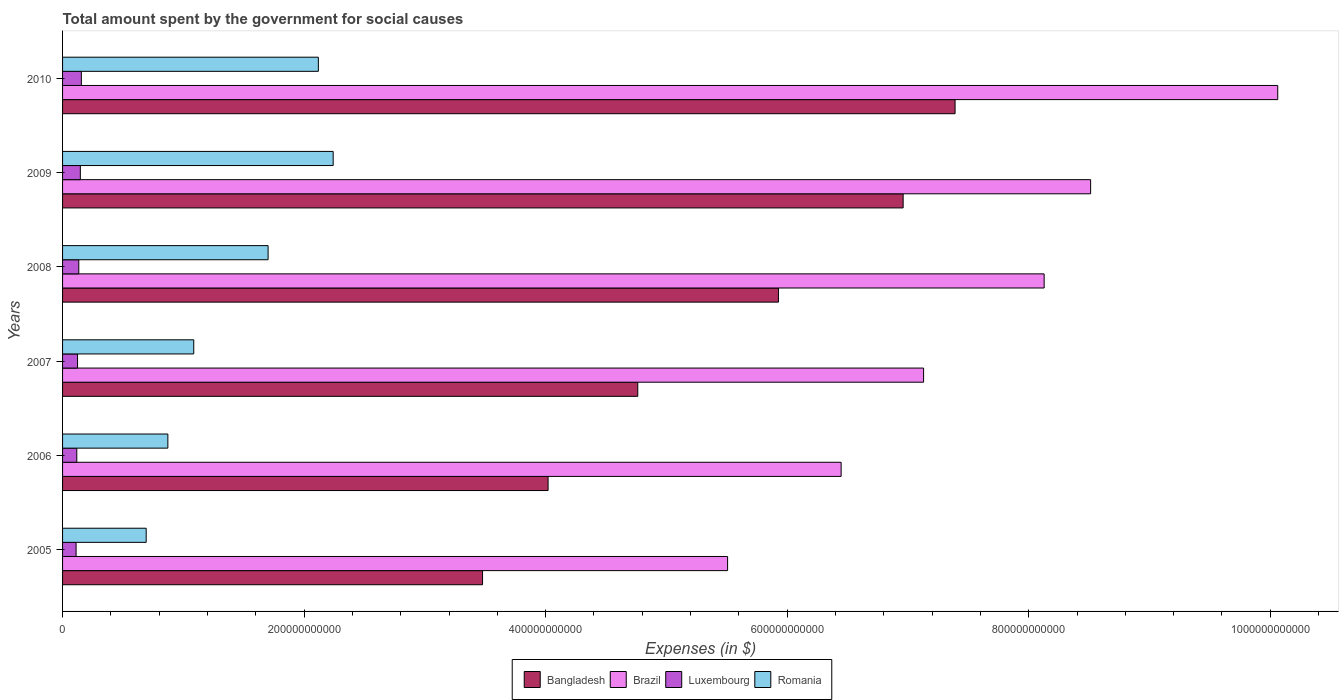How many different coloured bars are there?
Your response must be concise. 4. How many groups of bars are there?
Offer a very short reply. 6. Are the number of bars per tick equal to the number of legend labels?
Keep it short and to the point. Yes. What is the amount spent for social causes by the government in Romania in 2005?
Offer a terse response. 6.92e+1. Across all years, what is the maximum amount spent for social causes by the government in Romania?
Keep it short and to the point. 2.24e+11. Across all years, what is the minimum amount spent for social causes by the government in Bangladesh?
Ensure brevity in your answer.  3.48e+11. In which year was the amount spent for social causes by the government in Brazil minimum?
Give a very brief answer. 2005. What is the total amount spent for social causes by the government in Brazil in the graph?
Your answer should be very brief. 4.58e+12. What is the difference between the amount spent for social causes by the government in Brazil in 2008 and that in 2010?
Offer a terse response. -1.93e+11. What is the difference between the amount spent for social causes by the government in Brazil in 2008 and the amount spent for social causes by the government in Luxembourg in 2007?
Give a very brief answer. 8.00e+11. What is the average amount spent for social causes by the government in Romania per year?
Provide a short and direct response. 1.45e+11. In the year 2005, what is the difference between the amount spent for social causes by the government in Bangladesh and amount spent for social causes by the government in Luxembourg?
Your answer should be very brief. 3.37e+11. What is the ratio of the amount spent for social causes by the government in Romania in 2006 to that in 2007?
Ensure brevity in your answer.  0.8. Is the amount spent for social causes by the government in Brazil in 2005 less than that in 2010?
Provide a short and direct response. Yes. Is the difference between the amount spent for social causes by the government in Bangladesh in 2005 and 2006 greater than the difference between the amount spent for social causes by the government in Luxembourg in 2005 and 2006?
Make the answer very short. No. What is the difference between the highest and the second highest amount spent for social causes by the government in Romania?
Make the answer very short. 1.23e+1. What is the difference between the highest and the lowest amount spent for social causes by the government in Romania?
Provide a short and direct response. 1.55e+11. Is the sum of the amount spent for social causes by the government in Bangladesh in 2007 and 2010 greater than the maximum amount spent for social causes by the government in Romania across all years?
Provide a short and direct response. Yes. How many bars are there?
Make the answer very short. 24. Are all the bars in the graph horizontal?
Your answer should be very brief. Yes. How many years are there in the graph?
Your answer should be compact. 6. What is the difference between two consecutive major ticks on the X-axis?
Your answer should be compact. 2.00e+11. Are the values on the major ticks of X-axis written in scientific E-notation?
Ensure brevity in your answer.  No. Does the graph contain any zero values?
Ensure brevity in your answer.  No. Where does the legend appear in the graph?
Your response must be concise. Bottom center. How many legend labels are there?
Make the answer very short. 4. What is the title of the graph?
Offer a terse response. Total amount spent by the government for social causes. What is the label or title of the X-axis?
Make the answer very short. Expenses (in $). What is the label or title of the Y-axis?
Give a very brief answer. Years. What is the Expenses (in $) in Bangladesh in 2005?
Your answer should be very brief. 3.48e+11. What is the Expenses (in $) in Brazil in 2005?
Give a very brief answer. 5.51e+11. What is the Expenses (in $) of Luxembourg in 2005?
Offer a terse response. 1.12e+1. What is the Expenses (in $) in Romania in 2005?
Provide a succinct answer. 6.92e+1. What is the Expenses (in $) in Bangladesh in 2006?
Make the answer very short. 4.02e+11. What is the Expenses (in $) of Brazil in 2006?
Offer a very short reply. 6.45e+11. What is the Expenses (in $) in Luxembourg in 2006?
Give a very brief answer. 1.18e+1. What is the Expenses (in $) in Romania in 2006?
Provide a short and direct response. 8.72e+1. What is the Expenses (in $) in Bangladesh in 2007?
Offer a terse response. 4.76e+11. What is the Expenses (in $) of Brazil in 2007?
Ensure brevity in your answer.  7.13e+11. What is the Expenses (in $) in Luxembourg in 2007?
Offer a very short reply. 1.24e+1. What is the Expenses (in $) in Romania in 2007?
Provide a succinct answer. 1.09e+11. What is the Expenses (in $) of Bangladesh in 2008?
Give a very brief answer. 5.93e+11. What is the Expenses (in $) of Brazil in 2008?
Your answer should be compact. 8.13e+11. What is the Expenses (in $) of Luxembourg in 2008?
Make the answer very short. 1.34e+1. What is the Expenses (in $) in Romania in 2008?
Offer a very short reply. 1.70e+11. What is the Expenses (in $) of Bangladesh in 2009?
Provide a short and direct response. 6.96e+11. What is the Expenses (in $) in Brazil in 2009?
Your answer should be very brief. 8.51e+11. What is the Expenses (in $) in Luxembourg in 2009?
Offer a very short reply. 1.47e+1. What is the Expenses (in $) of Romania in 2009?
Keep it short and to the point. 2.24e+11. What is the Expenses (in $) of Bangladesh in 2010?
Offer a terse response. 7.39e+11. What is the Expenses (in $) in Brazil in 2010?
Give a very brief answer. 1.01e+12. What is the Expenses (in $) in Luxembourg in 2010?
Your answer should be compact. 1.56e+1. What is the Expenses (in $) in Romania in 2010?
Make the answer very short. 2.12e+11. Across all years, what is the maximum Expenses (in $) in Bangladesh?
Keep it short and to the point. 7.39e+11. Across all years, what is the maximum Expenses (in $) in Brazil?
Your answer should be very brief. 1.01e+12. Across all years, what is the maximum Expenses (in $) of Luxembourg?
Your answer should be very brief. 1.56e+1. Across all years, what is the maximum Expenses (in $) in Romania?
Offer a terse response. 2.24e+11. Across all years, what is the minimum Expenses (in $) in Bangladesh?
Your answer should be very brief. 3.48e+11. Across all years, what is the minimum Expenses (in $) in Brazil?
Your answer should be very brief. 5.51e+11. Across all years, what is the minimum Expenses (in $) of Luxembourg?
Offer a very short reply. 1.12e+1. Across all years, what is the minimum Expenses (in $) of Romania?
Offer a terse response. 6.92e+1. What is the total Expenses (in $) of Bangladesh in the graph?
Offer a very short reply. 3.25e+12. What is the total Expenses (in $) of Brazil in the graph?
Ensure brevity in your answer.  4.58e+12. What is the total Expenses (in $) in Luxembourg in the graph?
Offer a terse response. 7.91e+1. What is the total Expenses (in $) of Romania in the graph?
Your answer should be compact. 8.71e+11. What is the difference between the Expenses (in $) in Bangladesh in 2005 and that in 2006?
Keep it short and to the point. -5.43e+1. What is the difference between the Expenses (in $) of Brazil in 2005 and that in 2006?
Provide a succinct answer. -9.40e+1. What is the difference between the Expenses (in $) of Luxembourg in 2005 and that in 2006?
Offer a very short reply. -5.80e+08. What is the difference between the Expenses (in $) in Romania in 2005 and that in 2006?
Your answer should be very brief. -1.80e+1. What is the difference between the Expenses (in $) in Bangladesh in 2005 and that in 2007?
Provide a succinct answer. -1.29e+11. What is the difference between the Expenses (in $) in Brazil in 2005 and that in 2007?
Your answer should be very brief. -1.62e+11. What is the difference between the Expenses (in $) of Luxembourg in 2005 and that in 2007?
Offer a terse response. -1.21e+09. What is the difference between the Expenses (in $) of Romania in 2005 and that in 2007?
Your response must be concise. -3.94e+1. What is the difference between the Expenses (in $) in Bangladesh in 2005 and that in 2008?
Make the answer very short. -2.45e+11. What is the difference between the Expenses (in $) in Brazil in 2005 and that in 2008?
Give a very brief answer. -2.62e+11. What is the difference between the Expenses (in $) in Luxembourg in 2005 and that in 2008?
Provide a succinct answer. -2.24e+09. What is the difference between the Expenses (in $) in Romania in 2005 and that in 2008?
Offer a terse response. -1.01e+11. What is the difference between the Expenses (in $) of Bangladesh in 2005 and that in 2009?
Your answer should be compact. -3.48e+11. What is the difference between the Expenses (in $) of Brazil in 2005 and that in 2009?
Your answer should be compact. -3.01e+11. What is the difference between the Expenses (in $) in Luxembourg in 2005 and that in 2009?
Your answer should be very brief. -3.51e+09. What is the difference between the Expenses (in $) in Romania in 2005 and that in 2009?
Provide a succinct answer. -1.55e+11. What is the difference between the Expenses (in $) of Bangladesh in 2005 and that in 2010?
Offer a terse response. -3.91e+11. What is the difference between the Expenses (in $) in Brazil in 2005 and that in 2010?
Provide a short and direct response. -4.56e+11. What is the difference between the Expenses (in $) in Luxembourg in 2005 and that in 2010?
Offer a very short reply. -4.35e+09. What is the difference between the Expenses (in $) in Romania in 2005 and that in 2010?
Your answer should be very brief. -1.43e+11. What is the difference between the Expenses (in $) of Bangladesh in 2006 and that in 2007?
Your answer should be compact. -7.43e+1. What is the difference between the Expenses (in $) in Brazil in 2006 and that in 2007?
Your response must be concise. -6.83e+1. What is the difference between the Expenses (in $) of Luxembourg in 2006 and that in 2007?
Offer a terse response. -6.28e+08. What is the difference between the Expenses (in $) of Romania in 2006 and that in 2007?
Your answer should be compact. -2.14e+1. What is the difference between the Expenses (in $) in Bangladesh in 2006 and that in 2008?
Keep it short and to the point. -1.91e+11. What is the difference between the Expenses (in $) in Brazil in 2006 and that in 2008?
Ensure brevity in your answer.  -1.68e+11. What is the difference between the Expenses (in $) in Luxembourg in 2006 and that in 2008?
Make the answer very short. -1.66e+09. What is the difference between the Expenses (in $) in Romania in 2006 and that in 2008?
Provide a short and direct response. -8.30e+1. What is the difference between the Expenses (in $) in Bangladesh in 2006 and that in 2009?
Make the answer very short. -2.94e+11. What is the difference between the Expenses (in $) of Brazil in 2006 and that in 2009?
Your response must be concise. -2.07e+11. What is the difference between the Expenses (in $) of Luxembourg in 2006 and that in 2009?
Keep it short and to the point. -2.93e+09. What is the difference between the Expenses (in $) in Romania in 2006 and that in 2009?
Ensure brevity in your answer.  -1.37e+11. What is the difference between the Expenses (in $) of Bangladesh in 2006 and that in 2010?
Keep it short and to the point. -3.37e+11. What is the difference between the Expenses (in $) in Brazil in 2006 and that in 2010?
Your answer should be compact. -3.62e+11. What is the difference between the Expenses (in $) of Luxembourg in 2006 and that in 2010?
Provide a short and direct response. -3.77e+09. What is the difference between the Expenses (in $) in Romania in 2006 and that in 2010?
Ensure brevity in your answer.  -1.25e+11. What is the difference between the Expenses (in $) of Bangladesh in 2007 and that in 2008?
Keep it short and to the point. -1.16e+11. What is the difference between the Expenses (in $) in Brazil in 2007 and that in 2008?
Keep it short and to the point. -9.98e+1. What is the difference between the Expenses (in $) in Luxembourg in 2007 and that in 2008?
Provide a succinct answer. -1.03e+09. What is the difference between the Expenses (in $) of Romania in 2007 and that in 2008?
Ensure brevity in your answer.  -6.16e+1. What is the difference between the Expenses (in $) of Bangladesh in 2007 and that in 2009?
Your response must be concise. -2.20e+11. What is the difference between the Expenses (in $) of Brazil in 2007 and that in 2009?
Give a very brief answer. -1.38e+11. What is the difference between the Expenses (in $) in Luxembourg in 2007 and that in 2009?
Offer a very short reply. -2.31e+09. What is the difference between the Expenses (in $) in Romania in 2007 and that in 2009?
Your answer should be compact. -1.15e+11. What is the difference between the Expenses (in $) of Bangladesh in 2007 and that in 2010?
Keep it short and to the point. -2.63e+11. What is the difference between the Expenses (in $) in Brazil in 2007 and that in 2010?
Your answer should be compact. -2.93e+11. What is the difference between the Expenses (in $) in Luxembourg in 2007 and that in 2010?
Provide a succinct answer. -3.14e+09. What is the difference between the Expenses (in $) in Romania in 2007 and that in 2010?
Your response must be concise. -1.03e+11. What is the difference between the Expenses (in $) in Bangladesh in 2008 and that in 2009?
Keep it short and to the point. -1.03e+11. What is the difference between the Expenses (in $) in Brazil in 2008 and that in 2009?
Offer a very short reply. -3.85e+1. What is the difference between the Expenses (in $) in Luxembourg in 2008 and that in 2009?
Ensure brevity in your answer.  -1.27e+09. What is the difference between the Expenses (in $) in Romania in 2008 and that in 2009?
Give a very brief answer. -5.39e+1. What is the difference between the Expenses (in $) of Bangladesh in 2008 and that in 2010?
Provide a short and direct response. -1.46e+11. What is the difference between the Expenses (in $) of Brazil in 2008 and that in 2010?
Your response must be concise. -1.93e+11. What is the difference between the Expenses (in $) in Luxembourg in 2008 and that in 2010?
Make the answer very short. -2.11e+09. What is the difference between the Expenses (in $) of Romania in 2008 and that in 2010?
Offer a terse response. -4.16e+1. What is the difference between the Expenses (in $) in Bangladesh in 2009 and that in 2010?
Make the answer very short. -4.30e+1. What is the difference between the Expenses (in $) of Brazil in 2009 and that in 2010?
Offer a very short reply. -1.55e+11. What is the difference between the Expenses (in $) in Luxembourg in 2009 and that in 2010?
Offer a very short reply. -8.37e+08. What is the difference between the Expenses (in $) in Romania in 2009 and that in 2010?
Ensure brevity in your answer.  1.23e+1. What is the difference between the Expenses (in $) in Bangladesh in 2005 and the Expenses (in $) in Brazil in 2006?
Provide a succinct answer. -2.97e+11. What is the difference between the Expenses (in $) of Bangladesh in 2005 and the Expenses (in $) of Luxembourg in 2006?
Ensure brevity in your answer.  3.36e+11. What is the difference between the Expenses (in $) of Bangladesh in 2005 and the Expenses (in $) of Romania in 2006?
Give a very brief answer. 2.61e+11. What is the difference between the Expenses (in $) in Brazil in 2005 and the Expenses (in $) in Luxembourg in 2006?
Keep it short and to the point. 5.39e+11. What is the difference between the Expenses (in $) in Brazil in 2005 and the Expenses (in $) in Romania in 2006?
Keep it short and to the point. 4.63e+11. What is the difference between the Expenses (in $) in Luxembourg in 2005 and the Expenses (in $) in Romania in 2006?
Ensure brevity in your answer.  -7.60e+1. What is the difference between the Expenses (in $) in Bangladesh in 2005 and the Expenses (in $) in Brazil in 2007?
Keep it short and to the point. -3.65e+11. What is the difference between the Expenses (in $) in Bangladesh in 2005 and the Expenses (in $) in Luxembourg in 2007?
Your answer should be very brief. 3.35e+11. What is the difference between the Expenses (in $) in Bangladesh in 2005 and the Expenses (in $) in Romania in 2007?
Your answer should be very brief. 2.39e+11. What is the difference between the Expenses (in $) of Brazil in 2005 and the Expenses (in $) of Luxembourg in 2007?
Your answer should be very brief. 5.38e+11. What is the difference between the Expenses (in $) of Brazil in 2005 and the Expenses (in $) of Romania in 2007?
Keep it short and to the point. 4.42e+11. What is the difference between the Expenses (in $) of Luxembourg in 2005 and the Expenses (in $) of Romania in 2007?
Your response must be concise. -9.74e+1. What is the difference between the Expenses (in $) in Bangladesh in 2005 and the Expenses (in $) in Brazil in 2008?
Your answer should be very brief. -4.65e+11. What is the difference between the Expenses (in $) of Bangladesh in 2005 and the Expenses (in $) of Luxembourg in 2008?
Provide a succinct answer. 3.34e+11. What is the difference between the Expenses (in $) in Bangladesh in 2005 and the Expenses (in $) in Romania in 2008?
Keep it short and to the point. 1.78e+11. What is the difference between the Expenses (in $) of Brazil in 2005 and the Expenses (in $) of Luxembourg in 2008?
Ensure brevity in your answer.  5.37e+11. What is the difference between the Expenses (in $) in Brazil in 2005 and the Expenses (in $) in Romania in 2008?
Offer a terse response. 3.80e+11. What is the difference between the Expenses (in $) of Luxembourg in 2005 and the Expenses (in $) of Romania in 2008?
Your answer should be compact. -1.59e+11. What is the difference between the Expenses (in $) of Bangladesh in 2005 and the Expenses (in $) of Brazil in 2009?
Make the answer very short. -5.04e+11. What is the difference between the Expenses (in $) of Bangladesh in 2005 and the Expenses (in $) of Luxembourg in 2009?
Offer a terse response. 3.33e+11. What is the difference between the Expenses (in $) in Bangladesh in 2005 and the Expenses (in $) in Romania in 2009?
Keep it short and to the point. 1.24e+11. What is the difference between the Expenses (in $) of Brazil in 2005 and the Expenses (in $) of Luxembourg in 2009?
Provide a succinct answer. 5.36e+11. What is the difference between the Expenses (in $) in Brazil in 2005 and the Expenses (in $) in Romania in 2009?
Give a very brief answer. 3.27e+11. What is the difference between the Expenses (in $) in Luxembourg in 2005 and the Expenses (in $) in Romania in 2009?
Make the answer very short. -2.13e+11. What is the difference between the Expenses (in $) in Bangladesh in 2005 and the Expenses (in $) in Brazil in 2010?
Ensure brevity in your answer.  -6.58e+11. What is the difference between the Expenses (in $) of Bangladesh in 2005 and the Expenses (in $) of Luxembourg in 2010?
Give a very brief answer. 3.32e+11. What is the difference between the Expenses (in $) of Bangladesh in 2005 and the Expenses (in $) of Romania in 2010?
Provide a succinct answer. 1.36e+11. What is the difference between the Expenses (in $) in Brazil in 2005 and the Expenses (in $) in Luxembourg in 2010?
Your answer should be very brief. 5.35e+11. What is the difference between the Expenses (in $) of Brazil in 2005 and the Expenses (in $) of Romania in 2010?
Give a very brief answer. 3.39e+11. What is the difference between the Expenses (in $) in Luxembourg in 2005 and the Expenses (in $) in Romania in 2010?
Keep it short and to the point. -2.01e+11. What is the difference between the Expenses (in $) of Bangladesh in 2006 and the Expenses (in $) of Brazil in 2007?
Make the answer very short. -3.11e+11. What is the difference between the Expenses (in $) in Bangladesh in 2006 and the Expenses (in $) in Luxembourg in 2007?
Ensure brevity in your answer.  3.90e+11. What is the difference between the Expenses (in $) of Bangladesh in 2006 and the Expenses (in $) of Romania in 2007?
Your answer should be very brief. 2.93e+11. What is the difference between the Expenses (in $) in Brazil in 2006 and the Expenses (in $) in Luxembourg in 2007?
Ensure brevity in your answer.  6.32e+11. What is the difference between the Expenses (in $) in Brazil in 2006 and the Expenses (in $) in Romania in 2007?
Your answer should be very brief. 5.36e+11. What is the difference between the Expenses (in $) in Luxembourg in 2006 and the Expenses (in $) in Romania in 2007?
Make the answer very short. -9.68e+1. What is the difference between the Expenses (in $) in Bangladesh in 2006 and the Expenses (in $) in Brazil in 2008?
Keep it short and to the point. -4.11e+11. What is the difference between the Expenses (in $) of Bangladesh in 2006 and the Expenses (in $) of Luxembourg in 2008?
Make the answer very short. 3.89e+11. What is the difference between the Expenses (in $) in Bangladesh in 2006 and the Expenses (in $) in Romania in 2008?
Give a very brief answer. 2.32e+11. What is the difference between the Expenses (in $) in Brazil in 2006 and the Expenses (in $) in Luxembourg in 2008?
Your response must be concise. 6.31e+11. What is the difference between the Expenses (in $) of Brazil in 2006 and the Expenses (in $) of Romania in 2008?
Keep it short and to the point. 4.74e+11. What is the difference between the Expenses (in $) in Luxembourg in 2006 and the Expenses (in $) in Romania in 2008?
Offer a very short reply. -1.58e+11. What is the difference between the Expenses (in $) of Bangladesh in 2006 and the Expenses (in $) of Brazil in 2009?
Keep it short and to the point. -4.49e+11. What is the difference between the Expenses (in $) in Bangladesh in 2006 and the Expenses (in $) in Luxembourg in 2009?
Ensure brevity in your answer.  3.87e+11. What is the difference between the Expenses (in $) of Bangladesh in 2006 and the Expenses (in $) of Romania in 2009?
Offer a very short reply. 1.78e+11. What is the difference between the Expenses (in $) in Brazil in 2006 and the Expenses (in $) in Luxembourg in 2009?
Your answer should be very brief. 6.30e+11. What is the difference between the Expenses (in $) of Brazil in 2006 and the Expenses (in $) of Romania in 2009?
Keep it short and to the point. 4.21e+11. What is the difference between the Expenses (in $) of Luxembourg in 2006 and the Expenses (in $) of Romania in 2009?
Provide a succinct answer. -2.12e+11. What is the difference between the Expenses (in $) in Bangladesh in 2006 and the Expenses (in $) in Brazil in 2010?
Keep it short and to the point. -6.04e+11. What is the difference between the Expenses (in $) in Bangladesh in 2006 and the Expenses (in $) in Luxembourg in 2010?
Keep it short and to the point. 3.86e+11. What is the difference between the Expenses (in $) in Bangladesh in 2006 and the Expenses (in $) in Romania in 2010?
Your response must be concise. 1.90e+11. What is the difference between the Expenses (in $) of Brazil in 2006 and the Expenses (in $) of Luxembourg in 2010?
Keep it short and to the point. 6.29e+11. What is the difference between the Expenses (in $) in Brazil in 2006 and the Expenses (in $) in Romania in 2010?
Provide a succinct answer. 4.33e+11. What is the difference between the Expenses (in $) of Luxembourg in 2006 and the Expenses (in $) of Romania in 2010?
Provide a short and direct response. -2.00e+11. What is the difference between the Expenses (in $) of Bangladesh in 2007 and the Expenses (in $) of Brazil in 2008?
Provide a succinct answer. -3.36e+11. What is the difference between the Expenses (in $) in Bangladesh in 2007 and the Expenses (in $) in Luxembourg in 2008?
Offer a terse response. 4.63e+11. What is the difference between the Expenses (in $) in Bangladesh in 2007 and the Expenses (in $) in Romania in 2008?
Make the answer very short. 3.06e+11. What is the difference between the Expenses (in $) in Brazil in 2007 and the Expenses (in $) in Luxembourg in 2008?
Your response must be concise. 7.00e+11. What is the difference between the Expenses (in $) of Brazil in 2007 and the Expenses (in $) of Romania in 2008?
Your response must be concise. 5.43e+11. What is the difference between the Expenses (in $) in Luxembourg in 2007 and the Expenses (in $) in Romania in 2008?
Ensure brevity in your answer.  -1.58e+11. What is the difference between the Expenses (in $) in Bangladesh in 2007 and the Expenses (in $) in Brazil in 2009?
Offer a very short reply. -3.75e+11. What is the difference between the Expenses (in $) in Bangladesh in 2007 and the Expenses (in $) in Luxembourg in 2009?
Make the answer very short. 4.62e+11. What is the difference between the Expenses (in $) in Bangladesh in 2007 and the Expenses (in $) in Romania in 2009?
Provide a succinct answer. 2.52e+11. What is the difference between the Expenses (in $) of Brazil in 2007 and the Expenses (in $) of Luxembourg in 2009?
Offer a terse response. 6.98e+11. What is the difference between the Expenses (in $) of Brazil in 2007 and the Expenses (in $) of Romania in 2009?
Provide a short and direct response. 4.89e+11. What is the difference between the Expenses (in $) in Luxembourg in 2007 and the Expenses (in $) in Romania in 2009?
Your answer should be very brief. -2.12e+11. What is the difference between the Expenses (in $) of Bangladesh in 2007 and the Expenses (in $) of Brazil in 2010?
Offer a very short reply. -5.30e+11. What is the difference between the Expenses (in $) of Bangladesh in 2007 and the Expenses (in $) of Luxembourg in 2010?
Offer a very short reply. 4.61e+11. What is the difference between the Expenses (in $) in Bangladesh in 2007 and the Expenses (in $) in Romania in 2010?
Ensure brevity in your answer.  2.64e+11. What is the difference between the Expenses (in $) in Brazil in 2007 and the Expenses (in $) in Luxembourg in 2010?
Offer a terse response. 6.97e+11. What is the difference between the Expenses (in $) in Brazil in 2007 and the Expenses (in $) in Romania in 2010?
Give a very brief answer. 5.01e+11. What is the difference between the Expenses (in $) of Luxembourg in 2007 and the Expenses (in $) of Romania in 2010?
Offer a terse response. -1.99e+11. What is the difference between the Expenses (in $) of Bangladesh in 2008 and the Expenses (in $) of Brazil in 2009?
Your response must be concise. -2.58e+11. What is the difference between the Expenses (in $) of Bangladesh in 2008 and the Expenses (in $) of Luxembourg in 2009?
Offer a very short reply. 5.78e+11. What is the difference between the Expenses (in $) in Bangladesh in 2008 and the Expenses (in $) in Romania in 2009?
Ensure brevity in your answer.  3.69e+11. What is the difference between the Expenses (in $) of Brazil in 2008 and the Expenses (in $) of Luxembourg in 2009?
Offer a terse response. 7.98e+11. What is the difference between the Expenses (in $) in Brazil in 2008 and the Expenses (in $) in Romania in 2009?
Your response must be concise. 5.89e+11. What is the difference between the Expenses (in $) in Luxembourg in 2008 and the Expenses (in $) in Romania in 2009?
Provide a short and direct response. -2.11e+11. What is the difference between the Expenses (in $) of Bangladesh in 2008 and the Expenses (in $) of Brazil in 2010?
Keep it short and to the point. -4.13e+11. What is the difference between the Expenses (in $) of Bangladesh in 2008 and the Expenses (in $) of Luxembourg in 2010?
Make the answer very short. 5.77e+11. What is the difference between the Expenses (in $) of Bangladesh in 2008 and the Expenses (in $) of Romania in 2010?
Offer a very short reply. 3.81e+11. What is the difference between the Expenses (in $) of Brazil in 2008 and the Expenses (in $) of Luxembourg in 2010?
Offer a very short reply. 7.97e+11. What is the difference between the Expenses (in $) in Brazil in 2008 and the Expenses (in $) in Romania in 2010?
Keep it short and to the point. 6.01e+11. What is the difference between the Expenses (in $) in Luxembourg in 2008 and the Expenses (in $) in Romania in 2010?
Provide a succinct answer. -1.98e+11. What is the difference between the Expenses (in $) of Bangladesh in 2009 and the Expenses (in $) of Brazil in 2010?
Provide a succinct answer. -3.10e+11. What is the difference between the Expenses (in $) in Bangladesh in 2009 and the Expenses (in $) in Luxembourg in 2010?
Offer a very short reply. 6.80e+11. What is the difference between the Expenses (in $) of Bangladesh in 2009 and the Expenses (in $) of Romania in 2010?
Your response must be concise. 4.84e+11. What is the difference between the Expenses (in $) in Brazil in 2009 and the Expenses (in $) in Luxembourg in 2010?
Your response must be concise. 8.36e+11. What is the difference between the Expenses (in $) in Brazil in 2009 and the Expenses (in $) in Romania in 2010?
Provide a short and direct response. 6.39e+11. What is the difference between the Expenses (in $) of Luxembourg in 2009 and the Expenses (in $) of Romania in 2010?
Offer a very short reply. -1.97e+11. What is the average Expenses (in $) of Bangladesh per year?
Your answer should be compact. 5.42e+11. What is the average Expenses (in $) of Brazil per year?
Offer a very short reply. 7.63e+11. What is the average Expenses (in $) in Luxembourg per year?
Provide a succinct answer. 1.32e+1. What is the average Expenses (in $) of Romania per year?
Your answer should be very brief. 1.45e+11. In the year 2005, what is the difference between the Expenses (in $) in Bangladesh and Expenses (in $) in Brazil?
Offer a very short reply. -2.03e+11. In the year 2005, what is the difference between the Expenses (in $) of Bangladesh and Expenses (in $) of Luxembourg?
Provide a short and direct response. 3.37e+11. In the year 2005, what is the difference between the Expenses (in $) of Bangladesh and Expenses (in $) of Romania?
Provide a short and direct response. 2.79e+11. In the year 2005, what is the difference between the Expenses (in $) of Brazil and Expenses (in $) of Luxembourg?
Your answer should be compact. 5.39e+11. In the year 2005, what is the difference between the Expenses (in $) of Brazil and Expenses (in $) of Romania?
Your answer should be compact. 4.81e+11. In the year 2005, what is the difference between the Expenses (in $) in Luxembourg and Expenses (in $) in Romania?
Your answer should be compact. -5.80e+1. In the year 2006, what is the difference between the Expenses (in $) of Bangladesh and Expenses (in $) of Brazil?
Provide a short and direct response. -2.43e+11. In the year 2006, what is the difference between the Expenses (in $) in Bangladesh and Expenses (in $) in Luxembourg?
Your answer should be compact. 3.90e+11. In the year 2006, what is the difference between the Expenses (in $) of Bangladesh and Expenses (in $) of Romania?
Make the answer very short. 3.15e+11. In the year 2006, what is the difference between the Expenses (in $) of Brazil and Expenses (in $) of Luxembourg?
Ensure brevity in your answer.  6.33e+11. In the year 2006, what is the difference between the Expenses (in $) of Brazil and Expenses (in $) of Romania?
Keep it short and to the point. 5.57e+11. In the year 2006, what is the difference between the Expenses (in $) in Luxembourg and Expenses (in $) in Romania?
Your answer should be very brief. -7.54e+1. In the year 2007, what is the difference between the Expenses (in $) in Bangladesh and Expenses (in $) in Brazil?
Your answer should be very brief. -2.37e+11. In the year 2007, what is the difference between the Expenses (in $) in Bangladesh and Expenses (in $) in Luxembourg?
Give a very brief answer. 4.64e+11. In the year 2007, what is the difference between the Expenses (in $) of Bangladesh and Expenses (in $) of Romania?
Make the answer very short. 3.68e+11. In the year 2007, what is the difference between the Expenses (in $) of Brazil and Expenses (in $) of Luxembourg?
Offer a terse response. 7.01e+11. In the year 2007, what is the difference between the Expenses (in $) of Brazil and Expenses (in $) of Romania?
Give a very brief answer. 6.04e+11. In the year 2007, what is the difference between the Expenses (in $) in Luxembourg and Expenses (in $) in Romania?
Ensure brevity in your answer.  -9.62e+1. In the year 2008, what is the difference between the Expenses (in $) of Bangladesh and Expenses (in $) of Brazil?
Provide a succinct answer. -2.20e+11. In the year 2008, what is the difference between the Expenses (in $) of Bangladesh and Expenses (in $) of Luxembourg?
Make the answer very short. 5.79e+11. In the year 2008, what is the difference between the Expenses (in $) of Bangladesh and Expenses (in $) of Romania?
Keep it short and to the point. 4.23e+11. In the year 2008, what is the difference between the Expenses (in $) in Brazil and Expenses (in $) in Luxembourg?
Provide a succinct answer. 7.99e+11. In the year 2008, what is the difference between the Expenses (in $) of Brazil and Expenses (in $) of Romania?
Keep it short and to the point. 6.43e+11. In the year 2008, what is the difference between the Expenses (in $) of Luxembourg and Expenses (in $) of Romania?
Offer a terse response. -1.57e+11. In the year 2009, what is the difference between the Expenses (in $) in Bangladesh and Expenses (in $) in Brazil?
Give a very brief answer. -1.55e+11. In the year 2009, what is the difference between the Expenses (in $) of Bangladesh and Expenses (in $) of Luxembourg?
Make the answer very short. 6.81e+11. In the year 2009, what is the difference between the Expenses (in $) of Bangladesh and Expenses (in $) of Romania?
Keep it short and to the point. 4.72e+11. In the year 2009, what is the difference between the Expenses (in $) in Brazil and Expenses (in $) in Luxembourg?
Make the answer very short. 8.37e+11. In the year 2009, what is the difference between the Expenses (in $) in Brazil and Expenses (in $) in Romania?
Ensure brevity in your answer.  6.27e+11. In the year 2009, what is the difference between the Expenses (in $) in Luxembourg and Expenses (in $) in Romania?
Offer a terse response. -2.09e+11. In the year 2010, what is the difference between the Expenses (in $) in Bangladesh and Expenses (in $) in Brazil?
Keep it short and to the point. -2.67e+11. In the year 2010, what is the difference between the Expenses (in $) in Bangladesh and Expenses (in $) in Luxembourg?
Ensure brevity in your answer.  7.23e+11. In the year 2010, what is the difference between the Expenses (in $) in Bangladesh and Expenses (in $) in Romania?
Make the answer very short. 5.27e+11. In the year 2010, what is the difference between the Expenses (in $) in Brazil and Expenses (in $) in Luxembourg?
Your answer should be very brief. 9.91e+11. In the year 2010, what is the difference between the Expenses (in $) in Brazil and Expenses (in $) in Romania?
Give a very brief answer. 7.94e+11. In the year 2010, what is the difference between the Expenses (in $) of Luxembourg and Expenses (in $) of Romania?
Make the answer very short. -1.96e+11. What is the ratio of the Expenses (in $) of Bangladesh in 2005 to that in 2006?
Your answer should be compact. 0.86. What is the ratio of the Expenses (in $) of Brazil in 2005 to that in 2006?
Your answer should be very brief. 0.85. What is the ratio of the Expenses (in $) in Luxembourg in 2005 to that in 2006?
Ensure brevity in your answer.  0.95. What is the ratio of the Expenses (in $) of Romania in 2005 to that in 2006?
Provide a short and direct response. 0.79. What is the ratio of the Expenses (in $) in Bangladesh in 2005 to that in 2007?
Offer a terse response. 0.73. What is the ratio of the Expenses (in $) in Brazil in 2005 to that in 2007?
Provide a short and direct response. 0.77. What is the ratio of the Expenses (in $) of Luxembourg in 2005 to that in 2007?
Offer a very short reply. 0.9. What is the ratio of the Expenses (in $) in Romania in 2005 to that in 2007?
Your response must be concise. 0.64. What is the ratio of the Expenses (in $) in Bangladesh in 2005 to that in 2008?
Provide a succinct answer. 0.59. What is the ratio of the Expenses (in $) in Brazil in 2005 to that in 2008?
Your answer should be very brief. 0.68. What is the ratio of the Expenses (in $) in Luxembourg in 2005 to that in 2008?
Your response must be concise. 0.83. What is the ratio of the Expenses (in $) in Romania in 2005 to that in 2008?
Your response must be concise. 0.41. What is the ratio of the Expenses (in $) of Bangladesh in 2005 to that in 2009?
Offer a very short reply. 0.5. What is the ratio of the Expenses (in $) in Brazil in 2005 to that in 2009?
Your answer should be compact. 0.65. What is the ratio of the Expenses (in $) of Luxembourg in 2005 to that in 2009?
Your answer should be compact. 0.76. What is the ratio of the Expenses (in $) in Romania in 2005 to that in 2009?
Keep it short and to the point. 0.31. What is the ratio of the Expenses (in $) of Bangladesh in 2005 to that in 2010?
Your answer should be very brief. 0.47. What is the ratio of the Expenses (in $) of Brazil in 2005 to that in 2010?
Your response must be concise. 0.55. What is the ratio of the Expenses (in $) of Luxembourg in 2005 to that in 2010?
Provide a succinct answer. 0.72. What is the ratio of the Expenses (in $) in Romania in 2005 to that in 2010?
Offer a very short reply. 0.33. What is the ratio of the Expenses (in $) of Bangladesh in 2006 to that in 2007?
Ensure brevity in your answer.  0.84. What is the ratio of the Expenses (in $) in Brazil in 2006 to that in 2007?
Your answer should be compact. 0.9. What is the ratio of the Expenses (in $) in Luxembourg in 2006 to that in 2007?
Your response must be concise. 0.95. What is the ratio of the Expenses (in $) of Romania in 2006 to that in 2007?
Your response must be concise. 0.8. What is the ratio of the Expenses (in $) in Bangladesh in 2006 to that in 2008?
Give a very brief answer. 0.68. What is the ratio of the Expenses (in $) in Brazil in 2006 to that in 2008?
Your answer should be compact. 0.79. What is the ratio of the Expenses (in $) in Luxembourg in 2006 to that in 2008?
Your answer should be very brief. 0.88. What is the ratio of the Expenses (in $) in Romania in 2006 to that in 2008?
Provide a succinct answer. 0.51. What is the ratio of the Expenses (in $) of Bangladesh in 2006 to that in 2009?
Offer a terse response. 0.58. What is the ratio of the Expenses (in $) in Brazil in 2006 to that in 2009?
Provide a succinct answer. 0.76. What is the ratio of the Expenses (in $) of Luxembourg in 2006 to that in 2009?
Keep it short and to the point. 0.8. What is the ratio of the Expenses (in $) of Romania in 2006 to that in 2009?
Provide a short and direct response. 0.39. What is the ratio of the Expenses (in $) in Bangladesh in 2006 to that in 2010?
Give a very brief answer. 0.54. What is the ratio of the Expenses (in $) in Brazil in 2006 to that in 2010?
Provide a short and direct response. 0.64. What is the ratio of the Expenses (in $) in Luxembourg in 2006 to that in 2010?
Your answer should be compact. 0.76. What is the ratio of the Expenses (in $) of Romania in 2006 to that in 2010?
Offer a very short reply. 0.41. What is the ratio of the Expenses (in $) of Bangladesh in 2007 to that in 2008?
Make the answer very short. 0.8. What is the ratio of the Expenses (in $) of Brazil in 2007 to that in 2008?
Your answer should be compact. 0.88. What is the ratio of the Expenses (in $) of Luxembourg in 2007 to that in 2008?
Offer a terse response. 0.92. What is the ratio of the Expenses (in $) in Romania in 2007 to that in 2008?
Your response must be concise. 0.64. What is the ratio of the Expenses (in $) in Bangladesh in 2007 to that in 2009?
Your answer should be very brief. 0.68. What is the ratio of the Expenses (in $) in Brazil in 2007 to that in 2009?
Your answer should be very brief. 0.84. What is the ratio of the Expenses (in $) of Luxembourg in 2007 to that in 2009?
Offer a very short reply. 0.84. What is the ratio of the Expenses (in $) in Romania in 2007 to that in 2009?
Make the answer very short. 0.48. What is the ratio of the Expenses (in $) of Bangladesh in 2007 to that in 2010?
Offer a terse response. 0.64. What is the ratio of the Expenses (in $) of Brazil in 2007 to that in 2010?
Your response must be concise. 0.71. What is the ratio of the Expenses (in $) in Luxembourg in 2007 to that in 2010?
Make the answer very short. 0.8. What is the ratio of the Expenses (in $) of Romania in 2007 to that in 2010?
Your answer should be compact. 0.51. What is the ratio of the Expenses (in $) of Bangladesh in 2008 to that in 2009?
Your answer should be very brief. 0.85. What is the ratio of the Expenses (in $) of Brazil in 2008 to that in 2009?
Your answer should be very brief. 0.95. What is the ratio of the Expenses (in $) of Luxembourg in 2008 to that in 2009?
Your response must be concise. 0.91. What is the ratio of the Expenses (in $) in Romania in 2008 to that in 2009?
Make the answer very short. 0.76. What is the ratio of the Expenses (in $) of Bangladesh in 2008 to that in 2010?
Provide a succinct answer. 0.8. What is the ratio of the Expenses (in $) in Brazil in 2008 to that in 2010?
Offer a very short reply. 0.81. What is the ratio of the Expenses (in $) in Luxembourg in 2008 to that in 2010?
Your answer should be very brief. 0.86. What is the ratio of the Expenses (in $) of Romania in 2008 to that in 2010?
Make the answer very short. 0.8. What is the ratio of the Expenses (in $) of Bangladesh in 2009 to that in 2010?
Your answer should be compact. 0.94. What is the ratio of the Expenses (in $) in Brazil in 2009 to that in 2010?
Offer a terse response. 0.85. What is the ratio of the Expenses (in $) of Luxembourg in 2009 to that in 2010?
Offer a terse response. 0.95. What is the ratio of the Expenses (in $) of Romania in 2009 to that in 2010?
Your response must be concise. 1.06. What is the difference between the highest and the second highest Expenses (in $) of Bangladesh?
Give a very brief answer. 4.30e+1. What is the difference between the highest and the second highest Expenses (in $) of Brazil?
Your response must be concise. 1.55e+11. What is the difference between the highest and the second highest Expenses (in $) of Luxembourg?
Ensure brevity in your answer.  8.37e+08. What is the difference between the highest and the second highest Expenses (in $) of Romania?
Offer a terse response. 1.23e+1. What is the difference between the highest and the lowest Expenses (in $) in Bangladesh?
Make the answer very short. 3.91e+11. What is the difference between the highest and the lowest Expenses (in $) in Brazil?
Your answer should be compact. 4.56e+11. What is the difference between the highest and the lowest Expenses (in $) of Luxembourg?
Your answer should be compact. 4.35e+09. What is the difference between the highest and the lowest Expenses (in $) in Romania?
Keep it short and to the point. 1.55e+11. 